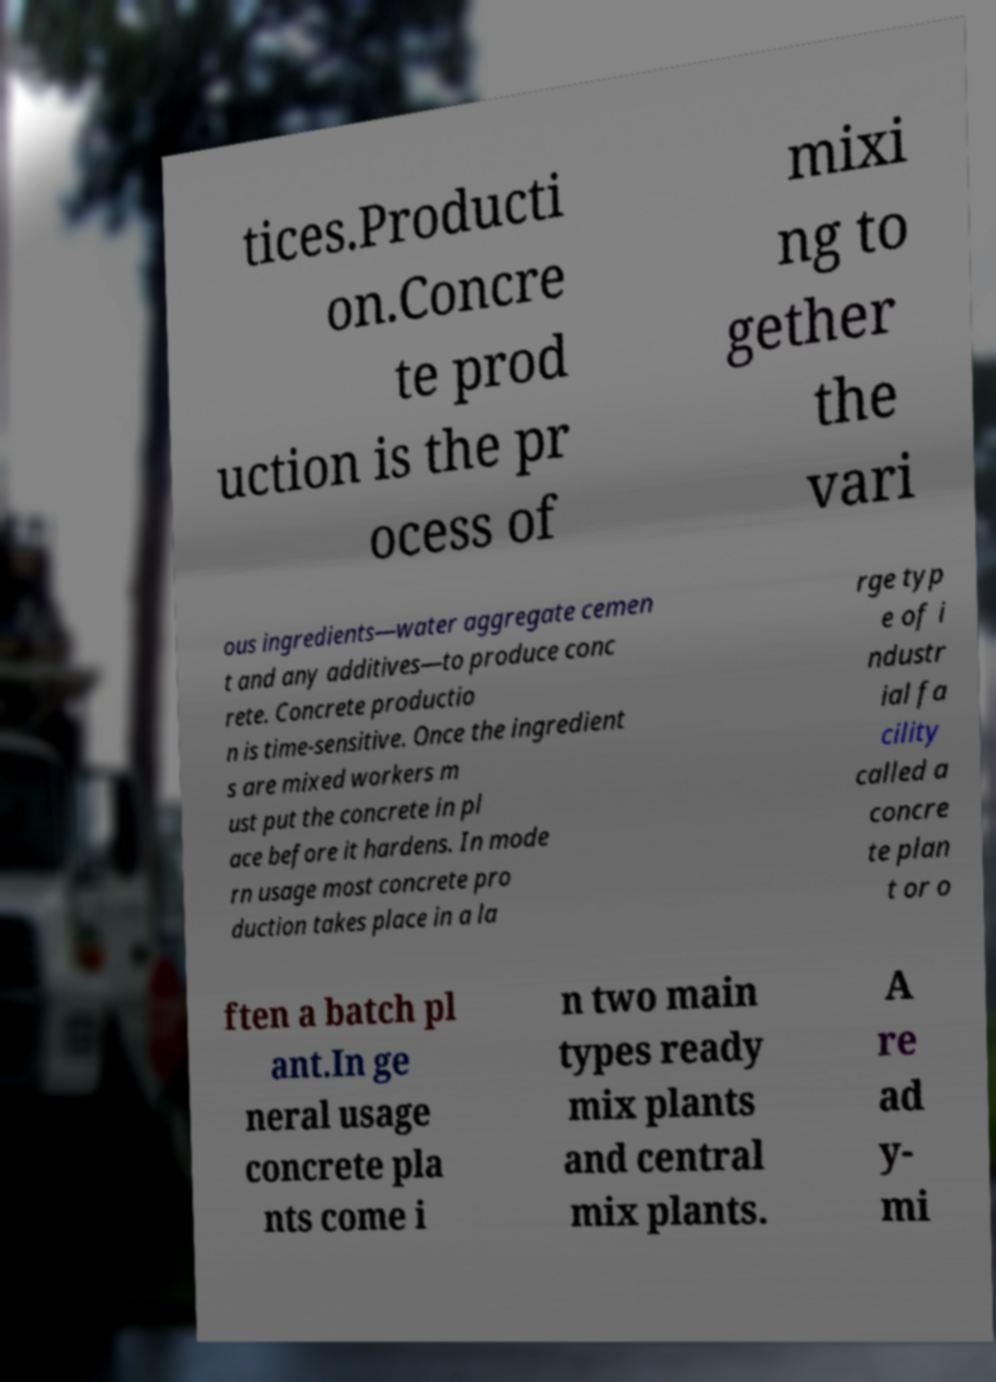There's text embedded in this image that I need extracted. Can you transcribe it verbatim? tices.Producti on.Concre te prod uction is the pr ocess of mixi ng to gether the vari ous ingredients—water aggregate cemen t and any additives—to produce conc rete. Concrete productio n is time-sensitive. Once the ingredient s are mixed workers m ust put the concrete in pl ace before it hardens. In mode rn usage most concrete pro duction takes place in a la rge typ e of i ndustr ial fa cility called a concre te plan t or o ften a batch pl ant.In ge neral usage concrete pla nts come i n two main types ready mix plants and central mix plants. A re ad y- mi 